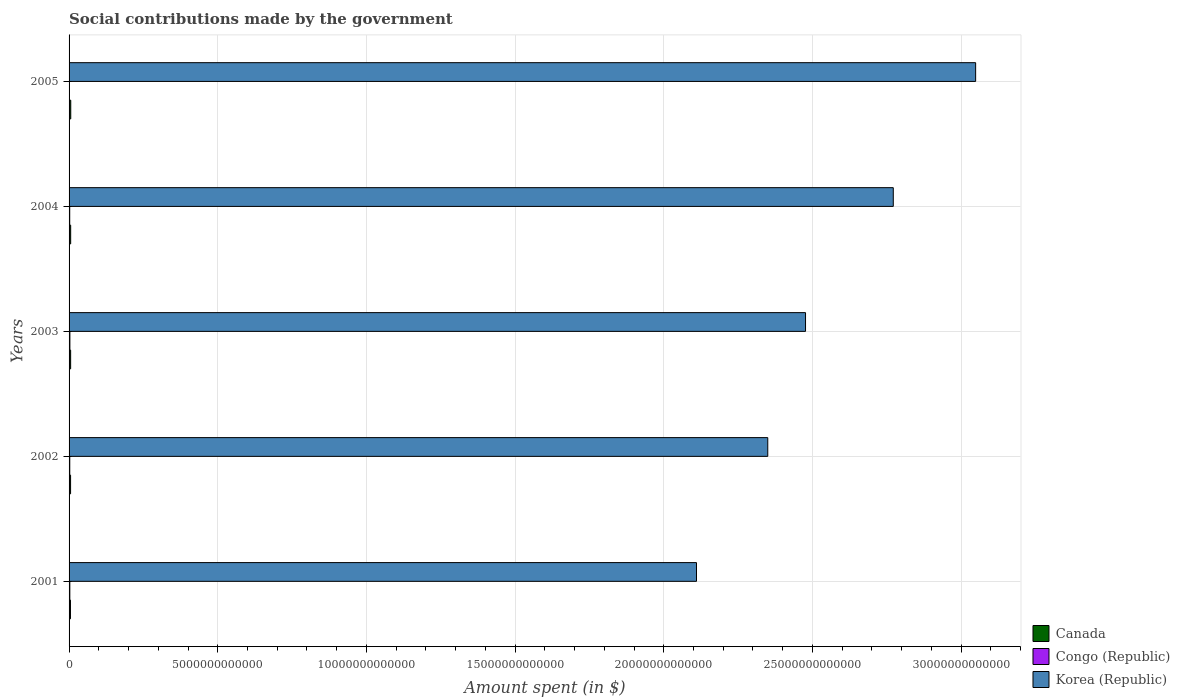How many groups of bars are there?
Keep it short and to the point. 5. How many bars are there on the 2nd tick from the top?
Provide a succinct answer. 3. What is the amount spent on social contributions in Congo (Republic) in 2005?
Give a very brief answer. 1.20e+1. Across all years, what is the maximum amount spent on social contributions in Korea (Republic)?
Provide a succinct answer. 3.05e+13. Across all years, what is the minimum amount spent on social contributions in Korea (Republic)?
Ensure brevity in your answer.  2.11e+13. In which year was the amount spent on social contributions in Korea (Republic) maximum?
Your answer should be compact. 2005. In which year was the amount spent on social contributions in Korea (Republic) minimum?
Offer a very short reply. 2001. What is the total amount spent on social contributions in Korea (Republic) in the graph?
Ensure brevity in your answer.  1.28e+14. What is the difference between the amount spent on social contributions in Canada in 2001 and that in 2005?
Keep it short and to the point. -9.70e+09. What is the difference between the amount spent on social contributions in Congo (Republic) in 2004 and the amount spent on social contributions in Canada in 2001?
Give a very brief answer. -2.50e+1. What is the average amount spent on social contributions in Congo (Republic) per year?
Offer a very short reply. 2.20e+1. In the year 2002, what is the difference between the amount spent on social contributions in Congo (Republic) and amount spent on social contributions in Korea (Republic)?
Provide a succinct answer. -2.35e+13. What is the ratio of the amount spent on social contributions in Canada in 2004 to that in 2005?
Your answer should be very brief. 0.95. Is the amount spent on social contributions in Congo (Republic) in 2002 less than that in 2005?
Provide a succinct answer. No. Is the difference between the amount spent on social contributions in Congo (Republic) in 2001 and 2003 greater than the difference between the amount spent on social contributions in Korea (Republic) in 2001 and 2003?
Provide a succinct answer. Yes. What is the difference between the highest and the second highest amount spent on social contributions in Korea (Republic)?
Your answer should be very brief. 2.77e+12. What is the difference between the highest and the lowest amount spent on social contributions in Korea (Republic)?
Your answer should be very brief. 9.39e+12. In how many years, is the amount spent on social contributions in Canada greater than the average amount spent on social contributions in Canada taken over all years?
Offer a terse response. 3. What does the 2nd bar from the top in 2005 represents?
Offer a very short reply. Congo (Republic). What does the 3rd bar from the bottom in 2005 represents?
Keep it short and to the point. Korea (Republic). Are all the bars in the graph horizontal?
Provide a short and direct response. Yes. What is the difference between two consecutive major ticks on the X-axis?
Offer a very short reply. 5.00e+12. Does the graph contain any zero values?
Your response must be concise. No. How many legend labels are there?
Keep it short and to the point. 3. How are the legend labels stacked?
Make the answer very short. Vertical. What is the title of the graph?
Provide a short and direct response. Social contributions made by the government. What is the label or title of the X-axis?
Provide a succinct answer. Amount spent (in $). What is the label or title of the Y-axis?
Provide a short and direct response. Years. What is the Amount spent (in $) of Canada in 2001?
Provide a short and direct response. 4.70e+1. What is the Amount spent (in $) of Congo (Republic) in 2001?
Your response must be concise. 2.53e+1. What is the Amount spent (in $) of Korea (Republic) in 2001?
Your response must be concise. 2.11e+13. What is the Amount spent (in $) in Canada in 2002?
Your answer should be very brief. 5.07e+1. What is the Amount spent (in $) of Congo (Republic) in 2002?
Your response must be concise. 2.32e+1. What is the Amount spent (in $) in Korea (Republic) in 2002?
Your response must be concise. 2.35e+13. What is the Amount spent (in $) of Canada in 2003?
Provide a short and direct response. 5.30e+1. What is the Amount spent (in $) in Congo (Republic) in 2003?
Offer a very short reply. 2.75e+1. What is the Amount spent (in $) of Korea (Republic) in 2003?
Offer a terse response. 2.48e+13. What is the Amount spent (in $) in Canada in 2004?
Give a very brief answer. 5.40e+1. What is the Amount spent (in $) of Congo (Republic) in 2004?
Your answer should be compact. 2.20e+1. What is the Amount spent (in $) of Korea (Republic) in 2004?
Your response must be concise. 2.77e+13. What is the Amount spent (in $) in Canada in 2005?
Provide a short and direct response. 5.67e+1. What is the Amount spent (in $) in Congo (Republic) in 2005?
Your answer should be very brief. 1.20e+1. What is the Amount spent (in $) in Korea (Republic) in 2005?
Give a very brief answer. 3.05e+13. Across all years, what is the maximum Amount spent (in $) of Canada?
Provide a succinct answer. 5.67e+1. Across all years, what is the maximum Amount spent (in $) of Congo (Republic)?
Make the answer very short. 2.75e+1. Across all years, what is the maximum Amount spent (in $) of Korea (Republic)?
Give a very brief answer. 3.05e+13. Across all years, what is the minimum Amount spent (in $) of Canada?
Make the answer very short. 4.70e+1. Across all years, what is the minimum Amount spent (in $) of Congo (Republic)?
Your answer should be compact. 1.20e+1. Across all years, what is the minimum Amount spent (in $) of Korea (Republic)?
Offer a terse response. 2.11e+13. What is the total Amount spent (in $) in Canada in the graph?
Provide a succinct answer. 2.61e+11. What is the total Amount spent (in $) in Congo (Republic) in the graph?
Offer a very short reply. 1.10e+11. What is the total Amount spent (in $) of Korea (Republic) in the graph?
Ensure brevity in your answer.  1.28e+14. What is the difference between the Amount spent (in $) of Canada in 2001 and that in 2002?
Provide a succinct answer. -3.78e+09. What is the difference between the Amount spent (in $) in Congo (Republic) in 2001 and that in 2002?
Your response must be concise. 2.11e+09. What is the difference between the Amount spent (in $) in Korea (Republic) in 2001 and that in 2002?
Offer a very short reply. -2.40e+12. What is the difference between the Amount spent (in $) of Canada in 2001 and that in 2003?
Provide a succinct answer. -6.08e+09. What is the difference between the Amount spent (in $) of Congo (Republic) in 2001 and that in 2003?
Ensure brevity in your answer.  -2.15e+09. What is the difference between the Amount spent (in $) of Korea (Republic) in 2001 and that in 2003?
Offer a terse response. -3.67e+12. What is the difference between the Amount spent (in $) in Canada in 2001 and that in 2004?
Offer a terse response. -7.01e+09. What is the difference between the Amount spent (in $) in Congo (Republic) in 2001 and that in 2004?
Your answer should be very brief. 3.31e+09. What is the difference between the Amount spent (in $) in Korea (Republic) in 2001 and that in 2004?
Provide a succinct answer. -6.62e+12. What is the difference between the Amount spent (in $) of Canada in 2001 and that in 2005?
Your answer should be very brief. -9.70e+09. What is the difference between the Amount spent (in $) of Congo (Republic) in 2001 and that in 2005?
Provide a succinct answer. 1.33e+1. What is the difference between the Amount spent (in $) of Korea (Republic) in 2001 and that in 2005?
Give a very brief answer. -9.39e+12. What is the difference between the Amount spent (in $) in Canada in 2002 and that in 2003?
Provide a succinct answer. -2.30e+09. What is the difference between the Amount spent (in $) of Congo (Republic) in 2002 and that in 2003?
Ensure brevity in your answer.  -4.26e+09. What is the difference between the Amount spent (in $) of Korea (Republic) in 2002 and that in 2003?
Give a very brief answer. -1.27e+12. What is the difference between the Amount spent (in $) in Canada in 2002 and that in 2004?
Keep it short and to the point. -3.24e+09. What is the difference between the Amount spent (in $) in Congo (Republic) in 2002 and that in 2004?
Ensure brevity in your answer.  1.21e+09. What is the difference between the Amount spent (in $) of Korea (Republic) in 2002 and that in 2004?
Your response must be concise. -4.22e+12. What is the difference between the Amount spent (in $) in Canada in 2002 and that in 2005?
Offer a terse response. -5.92e+09. What is the difference between the Amount spent (in $) of Congo (Republic) in 2002 and that in 2005?
Provide a succinct answer. 1.12e+1. What is the difference between the Amount spent (in $) of Korea (Republic) in 2002 and that in 2005?
Ensure brevity in your answer.  -6.99e+12. What is the difference between the Amount spent (in $) of Canada in 2003 and that in 2004?
Offer a terse response. -9.36e+08. What is the difference between the Amount spent (in $) of Congo (Republic) in 2003 and that in 2004?
Your answer should be compact. 5.46e+09. What is the difference between the Amount spent (in $) in Korea (Republic) in 2003 and that in 2004?
Ensure brevity in your answer.  -2.95e+12. What is the difference between the Amount spent (in $) in Canada in 2003 and that in 2005?
Your response must be concise. -3.62e+09. What is the difference between the Amount spent (in $) of Congo (Republic) in 2003 and that in 2005?
Provide a succinct answer. 1.55e+1. What is the difference between the Amount spent (in $) of Korea (Republic) in 2003 and that in 2005?
Offer a terse response. -5.72e+12. What is the difference between the Amount spent (in $) of Canada in 2004 and that in 2005?
Provide a short and direct response. -2.69e+09. What is the difference between the Amount spent (in $) in Congo (Republic) in 2004 and that in 2005?
Make the answer very short. 1.00e+1. What is the difference between the Amount spent (in $) in Korea (Republic) in 2004 and that in 2005?
Offer a terse response. -2.77e+12. What is the difference between the Amount spent (in $) of Canada in 2001 and the Amount spent (in $) of Congo (Republic) in 2002?
Your answer should be very brief. 2.38e+1. What is the difference between the Amount spent (in $) of Canada in 2001 and the Amount spent (in $) of Korea (Republic) in 2002?
Your response must be concise. -2.35e+13. What is the difference between the Amount spent (in $) in Congo (Republic) in 2001 and the Amount spent (in $) in Korea (Republic) in 2002?
Provide a succinct answer. -2.35e+13. What is the difference between the Amount spent (in $) of Canada in 2001 and the Amount spent (in $) of Congo (Republic) in 2003?
Make the answer very short. 1.95e+1. What is the difference between the Amount spent (in $) in Canada in 2001 and the Amount spent (in $) in Korea (Republic) in 2003?
Provide a short and direct response. -2.47e+13. What is the difference between the Amount spent (in $) of Congo (Republic) in 2001 and the Amount spent (in $) of Korea (Republic) in 2003?
Your answer should be very brief. -2.47e+13. What is the difference between the Amount spent (in $) in Canada in 2001 and the Amount spent (in $) in Congo (Republic) in 2004?
Ensure brevity in your answer.  2.50e+1. What is the difference between the Amount spent (in $) in Canada in 2001 and the Amount spent (in $) in Korea (Republic) in 2004?
Provide a succinct answer. -2.77e+13. What is the difference between the Amount spent (in $) of Congo (Republic) in 2001 and the Amount spent (in $) of Korea (Republic) in 2004?
Your answer should be very brief. -2.77e+13. What is the difference between the Amount spent (in $) in Canada in 2001 and the Amount spent (in $) in Congo (Republic) in 2005?
Offer a terse response. 3.50e+1. What is the difference between the Amount spent (in $) in Canada in 2001 and the Amount spent (in $) in Korea (Republic) in 2005?
Offer a very short reply. -3.04e+13. What is the difference between the Amount spent (in $) in Congo (Republic) in 2001 and the Amount spent (in $) in Korea (Republic) in 2005?
Ensure brevity in your answer.  -3.05e+13. What is the difference between the Amount spent (in $) of Canada in 2002 and the Amount spent (in $) of Congo (Republic) in 2003?
Keep it short and to the point. 2.33e+1. What is the difference between the Amount spent (in $) of Canada in 2002 and the Amount spent (in $) of Korea (Republic) in 2003?
Keep it short and to the point. -2.47e+13. What is the difference between the Amount spent (in $) of Congo (Republic) in 2002 and the Amount spent (in $) of Korea (Republic) in 2003?
Your answer should be compact. -2.47e+13. What is the difference between the Amount spent (in $) in Canada in 2002 and the Amount spent (in $) in Congo (Republic) in 2004?
Your answer should be compact. 2.87e+1. What is the difference between the Amount spent (in $) of Canada in 2002 and the Amount spent (in $) of Korea (Republic) in 2004?
Offer a very short reply. -2.77e+13. What is the difference between the Amount spent (in $) in Congo (Republic) in 2002 and the Amount spent (in $) in Korea (Republic) in 2004?
Your response must be concise. -2.77e+13. What is the difference between the Amount spent (in $) in Canada in 2002 and the Amount spent (in $) in Congo (Republic) in 2005?
Provide a short and direct response. 3.88e+1. What is the difference between the Amount spent (in $) in Canada in 2002 and the Amount spent (in $) in Korea (Republic) in 2005?
Ensure brevity in your answer.  -3.04e+13. What is the difference between the Amount spent (in $) in Congo (Republic) in 2002 and the Amount spent (in $) in Korea (Republic) in 2005?
Your answer should be very brief. -3.05e+13. What is the difference between the Amount spent (in $) of Canada in 2003 and the Amount spent (in $) of Congo (Republic) in 2004?
Your answer should be compact. 3.10e+1. What is the difference between the Amount spent (in $) in Canada in 2003 and the Amount spent (in $) in Korea (Republic) in 2004?
Make the answer very short. -2.77e+13. What is the difference between the Amount spent (in $) in Congo (Republic) in 2003 and the Amount spent (in $) in Korea (Republic) in 2004?
Provide a short and direct response. -2.77e+13. What is the difference between the Amount spent (in $) of Canada in 2003 and the Amount spent (in $) of Congo (Republic) in 2005?
Give a very brief answer. 4.11e+1. What is the difference between the Amount spent (in $) of Canada in 2003 and the Amount spent (in $) of Korea (Republic) in 2005?
Provide a succinct answer. -3.04e+13. What is the difference between the Amount spent (in $) in Congo (Republic) in 2003 and the Amount spent (in $) in Korea (Republic) in 2005?
Provide a succinct answer. -3.05e+13. What is the difference between the Amount spent (in $) in Canada in 2004 and the Amount spent (in $) in Congo (Republic) in 2005?
Offer a very short reply. 4.20e+1. What is the difference between the Amount spent (in $) in Canada in 2004 and the Amount spent (in $) in Korea (Republic) in 2005?
Offer a terse response. -3.04e+13. What is the difference between the Amount spent (in $) of Congo (Republic) in 2004 and the Amount spent (in $) of Korea (Republic) in 2005?
Your answer should be compact. -3.05e+13. What is the average Amount spent (in $) in Canada per year?
Offer a terse response. 5.23e+1. What is the average Amount spent (in $) of Congo (Republic) per year?
Offer a very short reply. 2.20e+1. What is the average Amount spent (in $) in Korea (Republic) per year?
Your answer should be very brief. 2.55e+13. In the year 2001, what is the difference between the Amount spent (in $) of Canada and Amount spent (in $) of Congo (Republic)?
Your answer should be compact. 2.16e+1. In the year 2001, what is the difference between the Amount spent (in $) of Canada and Amount spent (in $) of Korea (Republic)?
Keep it short and to the point. -2.11e+13. In the year 2001, what is the difference between the Amount spent (in $) of Congo (Republic) and Amount spent (in $) of Korea (Republic)?
Provide a short and direct response. -2.11e+13. In the year 2002, what is the difference between the Amount spent (in $) in Canada and Amount spent (in $) in Congo (Republic)?
Keep it short and to the point. 2.75e+1. In the year 2002, what is the difference between the Amount spent (in $) in Canada and Amount spent (in $) in Korea (Republic)?
Offer a very short reply. -2.34e+13. In the year 2002, what is the difference between the Amount spent (in $) of Congo (Republic) and Amount spent (in $) of Korea (Republic)?
Provide a succinct answer. -2.35e+13. In the year 2003, what is the difference between the Amount spent (in $) in Canada and Amount spent (in $) in Congo (Republic)?
Ensure brevity in your answer.  2.56e+1. In the year 2003, what is the difference between the Amount spent (in $) of Canada and Amount spent (in $) of Korea (Republic)?
Your answer should be very brief. -2.47e+13. In the year 2003, what is the difference between the Amount spent (in $) in Congo (Republic) and Amount spent (in $) in Korea (Republic)?
Offer a very short reply. -2.47e+13. In the year 2004, what is the difference between the Amount spent (in $) of Canada and Amount spent (in $) of Congo (Republic)?
Offer a very short reply. 3.20e+1. In the year 2004, what is the difference between the Amount spent (in $) in Canada and Amount spent (in $) in Korea (Republic)?
Ensure brevity in your answer.  -2.77e+13. In the year 2004, what is the difference between the Amount spent (in $) in Congo (Republic) and Amount spent (in $) in Korea (Republic)?
Your response must be concise. -2.77e+13. In the year 2005, what is the difference between the Amount spent (in $) of Canada and Amount spent (in $) of Congo (Republic)?
Give a very brief answer. 4.47e+1. In the year 2005, what is the difference between the Amount spent (in $) in Canada and Amount spent (in $) in Korea (Republic)?
Your answer should be compact. -3.04e+13. In the year 2005, what is the difference between the Amount spent (in $) in Congo (Republic) and Amount spent (in $) in Korea (Republic)?
Your response must be concise. -3.05e+13. What is the ratio of the Amount spent (in $) in Canada in 2001 to that in 2002?
Ensure brevity in your answer.  0.93. What is the ratio of the Amount spent (in $) of Congo (Republic) in 2001 to that in 2002?
Provide a succinct answer. 1.09. What is the ratio of the Amount spent (in $) of Korea (Republic) in 2001 to that in 2002?
Make the answer very short. 0.9. What is the ratio of the Amount spent (in $) in Canada in 2001 to that in 2003?
Your answer should be compact. 0.89. What is the ratio of the Amount spent (in $) of Congo (Republic) in 2001 to that in 2003?
Provide a short and direct response. 0.92. What is the ratio of the Amount spent (in $) of Korea (Republic) in 2001 to that in 2003?
Your answer should be compact. 0.85. What is the ratio of the Amount spent (in $) of Canada in 2001 to that in 2004?
Make the answer very short. 0.87. What is the ratio of the Amount spent (in $) of Congo (Republic) in 2001 to that in 2004?
Keep it short and to the point. 1.15. What is the ratio of the Amount spent (in $) of Korea (Republic) in 2001 to that in 2004?
Provide a short and direct response. 0.76. What is the ratio of the Amount spent (in $) of Canada in 2001 to that in 2005?
Your response must be concise. 0.83. What is the ratio of the Amount spent (in $) in Congo (Republic) in 2001 to that in 2005?
Keep it short and to the point. 2.12. What is the ratio of the Amount spent (in $) of Korea (Republic) in 2001 to that in 2005?
Give a very brief answer. 0.69. What is the ratio of the Amount spent (in $) of Canada in 2002 to that in 2003?
Provide a succinct answer. 0.96. What is the ratio of the Amount spent (in $) of Congo (Republic) in 2002 to that in 2003?
Ensure brevity in your answer.  0.84. What is the ratio of the Amount spent (in $) in Korea (Republic) in 2002 to that in 2003?
Provide a short and direct response. 0.95. What is the ratio of the Amount spent (in $) of Canada in 2002 to that in 2004?
Your answer should be very brief. 0.94. What is the ratio of the Amount spent (in $) in Congo (Republic) in 2002 to that in 2004?
Ensure brevity in your answer.  1.05. What is the ratio of the Amount spent (in $) of Korea (Republic) in 2002 to that in 2004?
Provide a short and direct response. 0.85. What is the ratio of the Amount spent (in $) of Canada in 2002 to that in 2005?
Keep it short and to the point. 0.9. What is the ratio of the Amount spent (in $) in Congo (Republic) in 2002 to that in 2005?
Keep it short and to the point. 1.94. What is the ratio of the Amount spent (in $) of Korea (Republic) in 2002 to that in 2005?
Provide a succinct answer. 0.77. What is the ratio of the Amount spent (in $) of Canada in 2003 to that in 2004?
Your answer should be compact. 0.98. What is the ratio of the Amount spent (in $) of Congo (Republic) in 2003 to that in 2004?
Your answer should be very brief. 1.25. What is the ratio of the Amount spent (in $) of Korea (Republic) in 2003 to that in 2004?
Keep it short and to the point. 0.89. What is the ratio of the Amount spent (in $) in Canada in 2003 to that in 2005?
Make the answer very short. 0.94. What is the ratio of the Amount spent (in $) in Congo (Republic) in 2003 to that in 2005?
Keep it short and to the point. 2.29. What is the ratio of the Amount spent (in $) of Korea (Republic) in 2003 to that in 2005?
Provide a succinct answer. 0.81. What is the ratio of the Amount spent (in $) in Canada in 2004 to that in 2005?
Your answer should be compact. 0.95. What is the ratio of the Amount spent (in $) in Congo (Republic) in 2004 to that in 2005?
Provide a succinct answer. 1.84. What is the ratio of the Amount spent (in $) of Korea (Republic) in 2004 to that in 2005?
Ensure brevity in your answer.  0.91. What is the difference between the highest and the second highest Amount spent (in $) of Canada?
Your response must be concise. 2.69e+09. What is the difference between the highest and the second highest Amount spent (in $) in Congo (Republic)?
Offer a very short reply. 2.15e+09. What is the difference between the highest and the second highest Amount spent (in $) in Korea (Republic)?
Your response must be concise. 2.77e+12. What is the difference between the highest and the lowest Amount spent (in $) in Canada?
Give a very brief answer. 9.70e+09. What is the difference between the highest and the lowest Amount spent (in $) of Congo (Republic)?
Make the answer very short. 1.55e+1. What is the difference between the highest and the lowest Amount spent (in $) of Korea (Republic)?
Your answer should be very brief. 9.39e+12. 